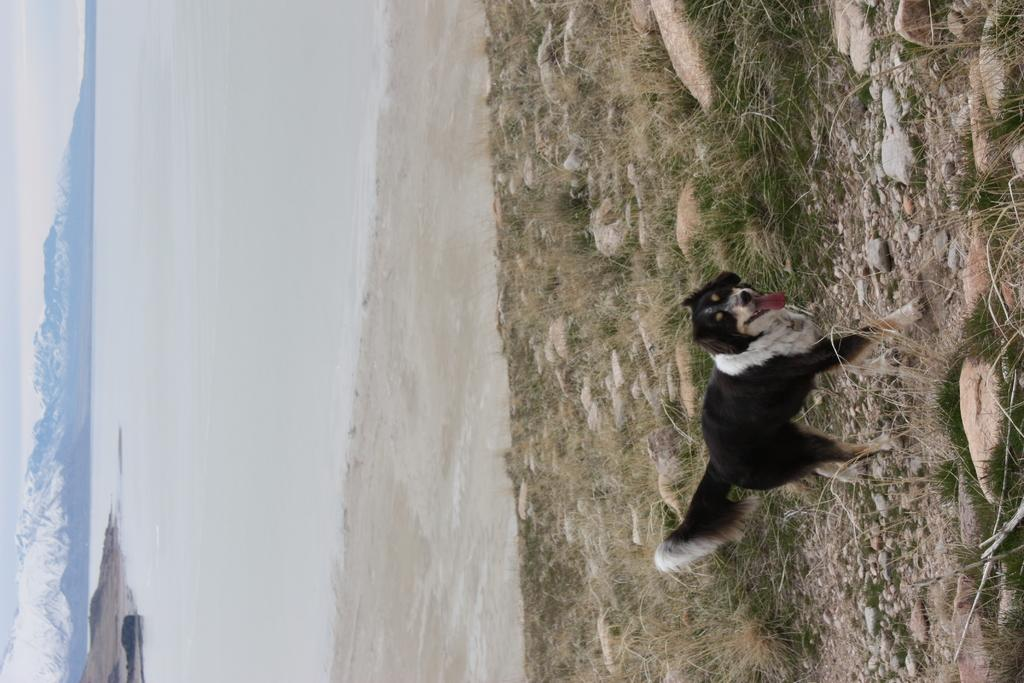What animal can be seen in the image? There is a dog in the image. What is the dog's position in the image? The dog is standing on the ground. What can be seen in the background of the image? There is water, stones, mountains, and the sky visible in the background of the image. What type of locket is the dog wearing around its neck in the image? There is no locket visible around the dog's neck in the image. How many bushes are present in the image? There is no mention of bushes in the provided facts, so it cannot be determined how many bushes are present in the image. 